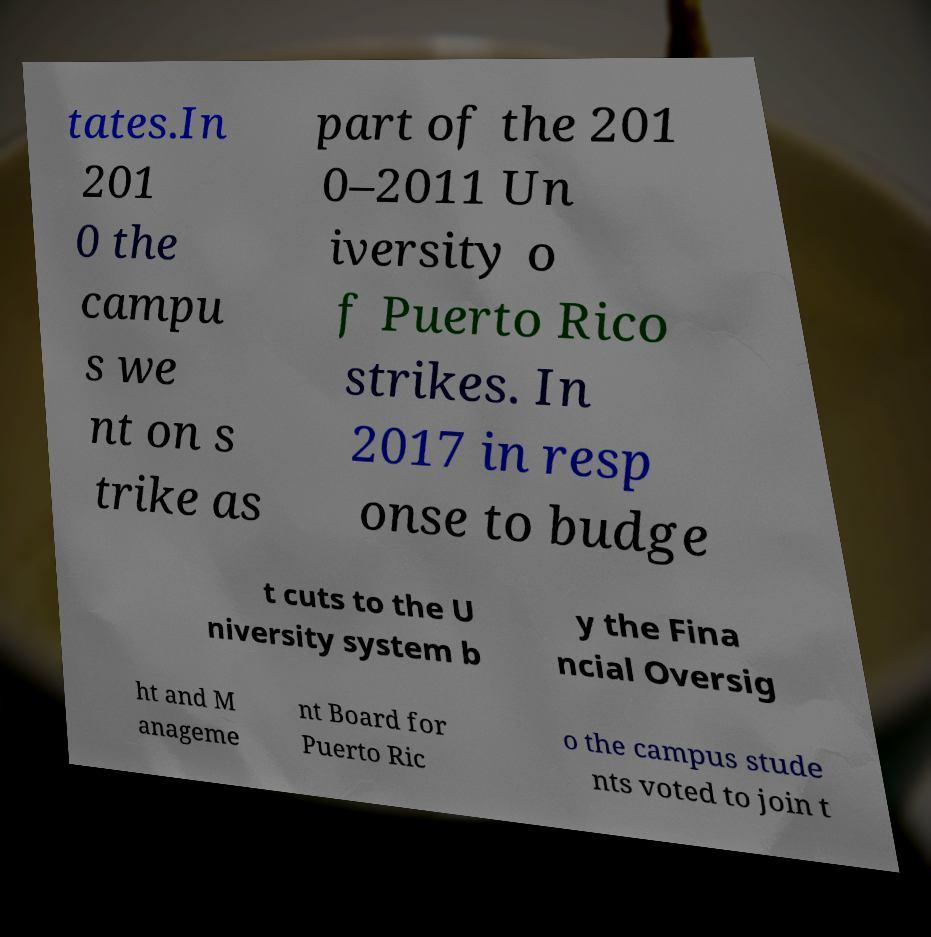I need the written content from this picture converted into text. Can you do that? tates.In 201 0 the campu s we nt on s trike as part of the 201 0–2011 Un iversity o f Puerto Rico strikes. In 2017 in resp onse to budge t cuts to the U niversity system b y the Fina ncial Oversig ht and M anageme nt Board for Puerto Ric o the campus stude nts voted to join t 